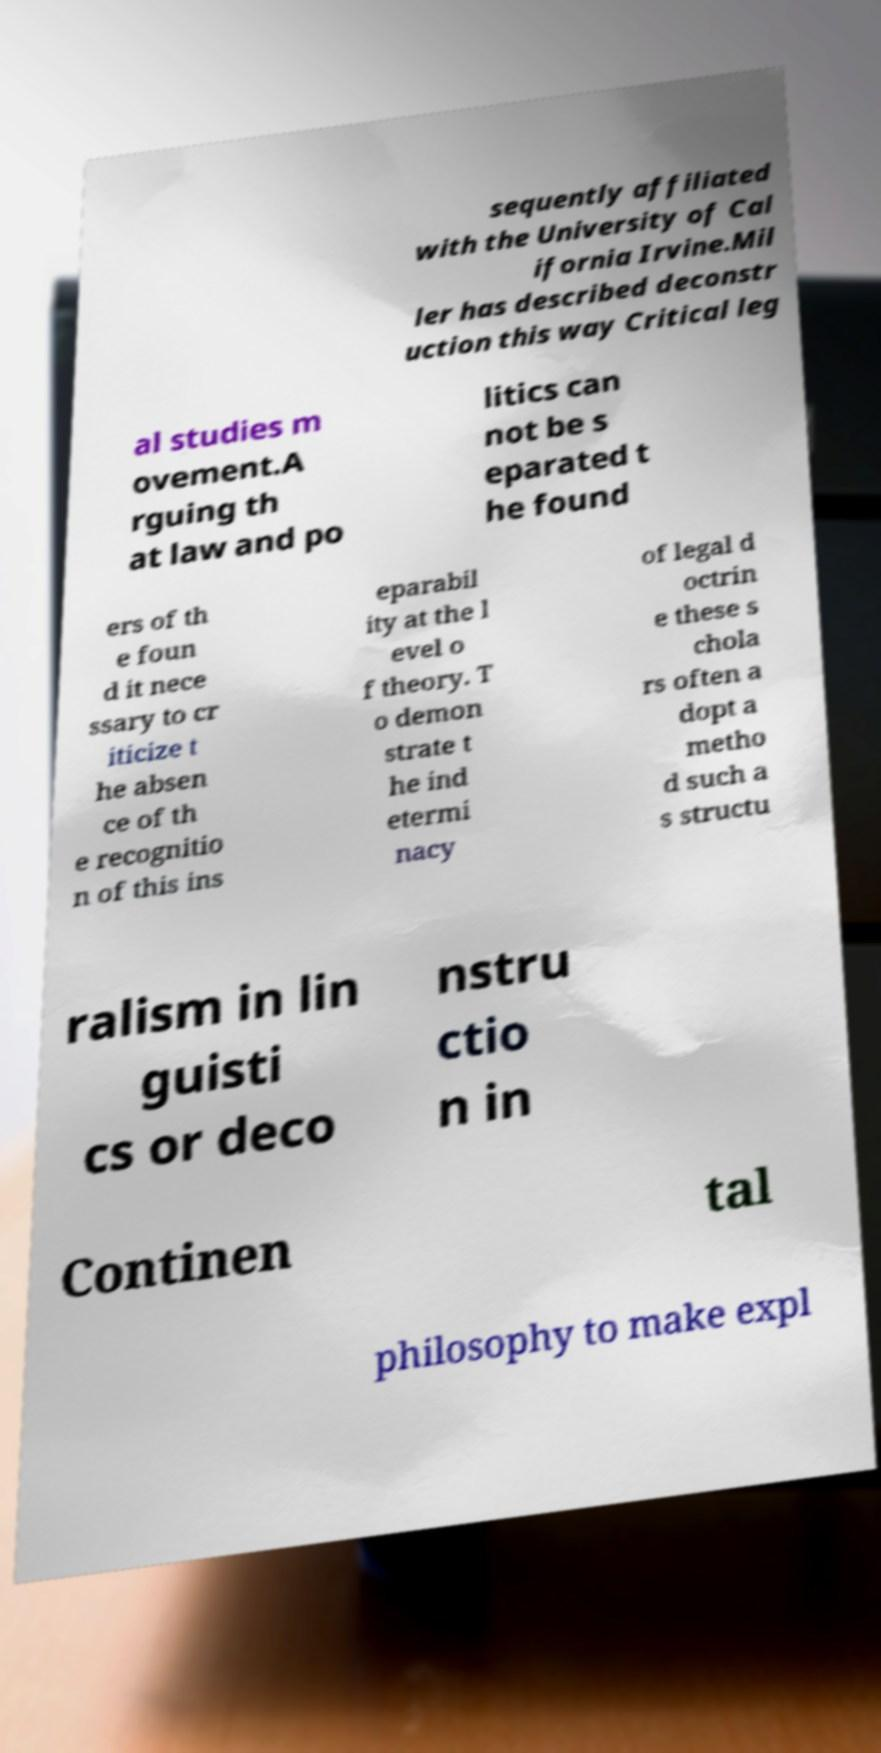I need the written content from this picture converted into text. Can you do that? sequently affiliated with the University of Cal ifornia Irvine.Mil ler has described deconstr uction this way Critical leg al studies m ovement.A rguing th at law and po litics can not be s eparated t he found ers of th e foun d it nece ssary to cr iticize t he absen ce of th e recognitio n of this ins eparabil ity at the l evel o f theory. T o demon strate t he ind etermi nacy of legal d octrin e these s chola rs often a dopt a metho d such a s structu ralism in lin guisti cs or deco nstru ctio n in Continen tal philosophy to make expl 